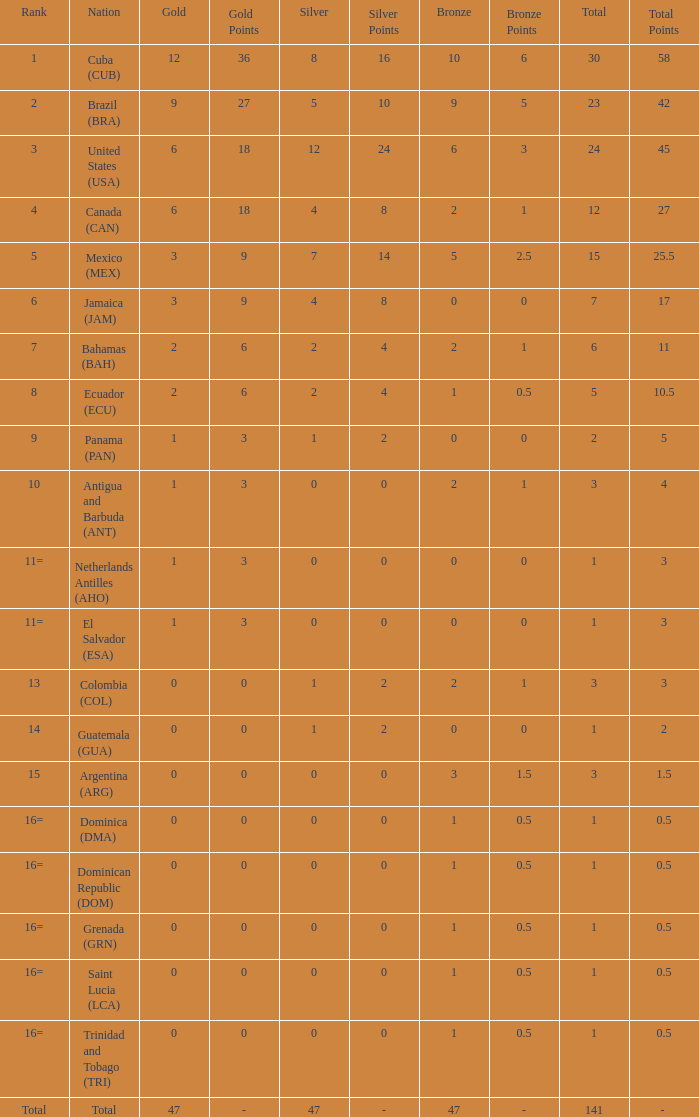What is the total gold with a total less than 1? None. 